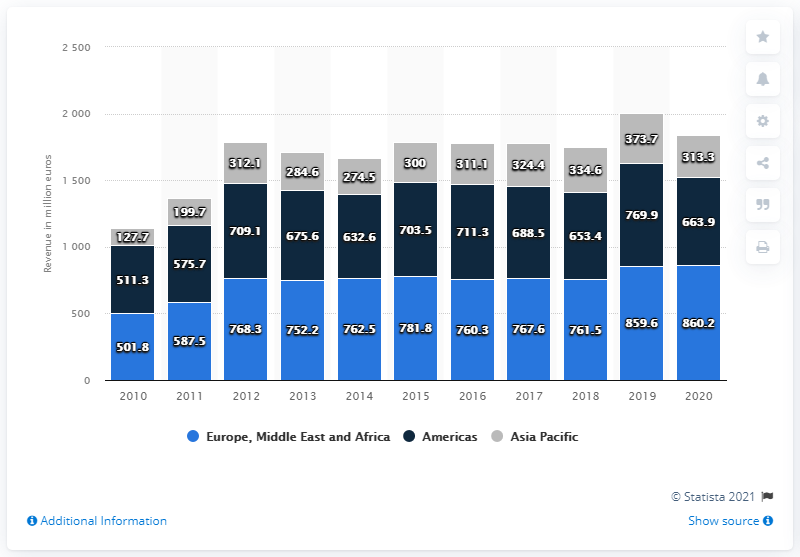Point out several critical features in this image. The value of navy blue is 511.3, which is the lowest value of the color in the range of measurements. The graph indicates the presence of three geographic regions. Ipsos generated $663.9 million in revenue in the Americas in 2020. 